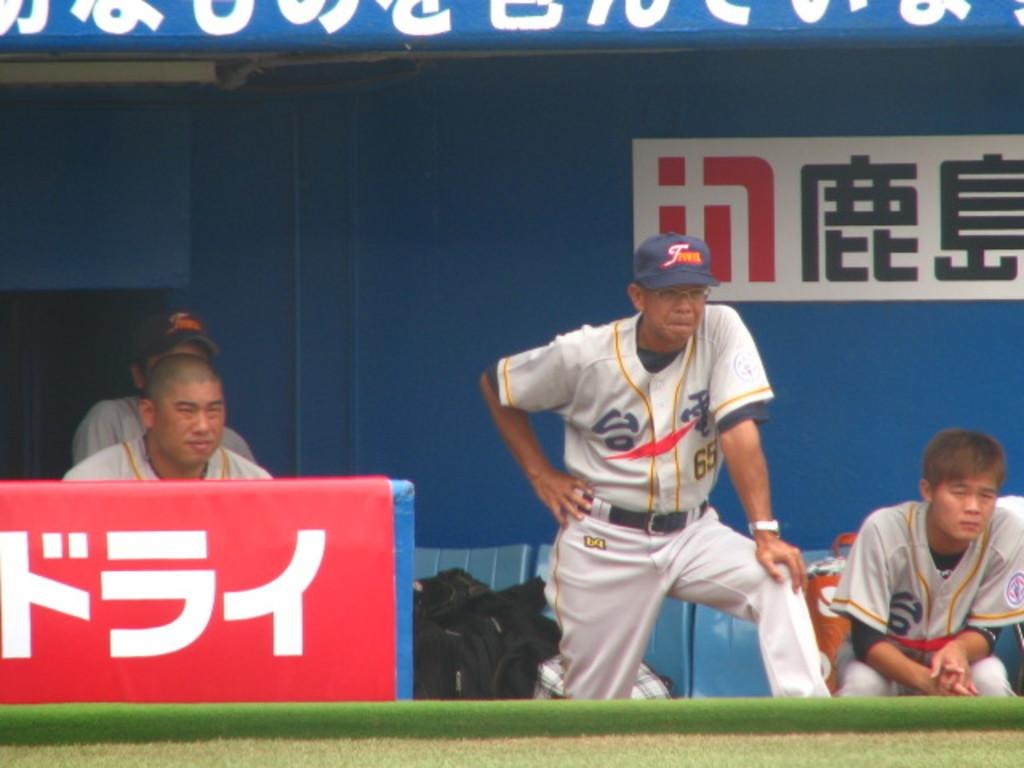<image>
Summarize the visual content of the image. A baseball dugout with foreign words and men sitting in the background and one standing. 